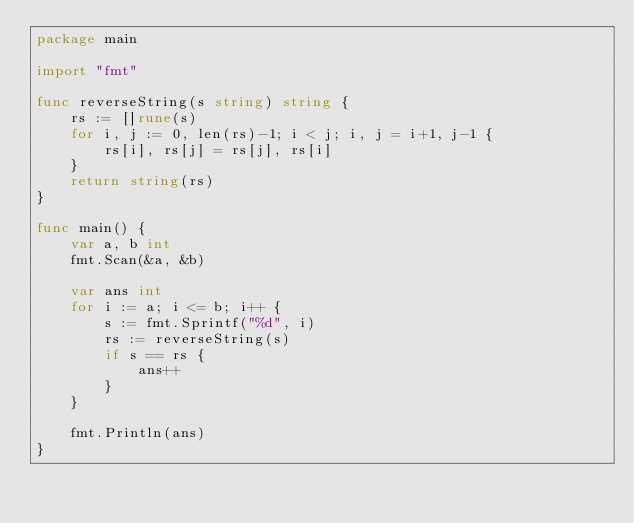Convert code to text. <code><loc_0><loc_0><loc_500><loc_500><_Go_>package main

import "fmt"

func reverseString(s string) string {
	rs := []rune(s)
	for i, j := 0, len(rs)-1; i < j; i, j = i+1, j-1 {
		rs[i], rs[j] = rs[j], rs[i]
	}
	return string(rs)
}

func main() {
	var a, b int
	fmt.Scan(&a, &b)

	var ans int
	for i := a; i <= b; i++ {
		s := fmt.Sprintf("%d", i)
		rs := reverseString(s)
		if s == rs {
			ans++
		}
	}

	fmt.Println(ans)
}
</code> 